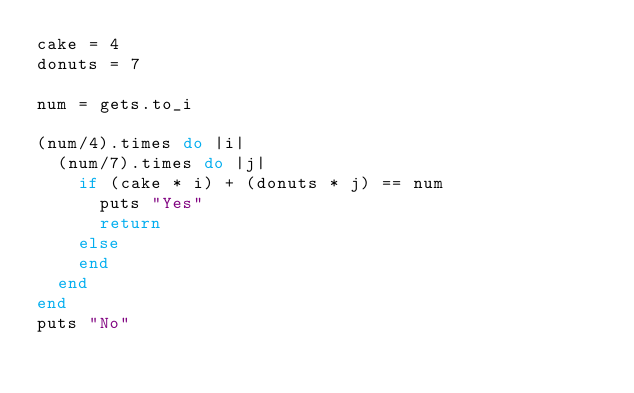Convert code to text. <code><loc_0><loc_0><loc_500><loc_500><_Ruby_>cake = 4
donuts = 7

num = gets.to_i

(num/4).times do |i|
  (num/7).times do |j|
    if (cake * i) + (donuts * j) == num
      puts "Yes"
      return
    else
    end
  end
end
puts "No"</code> 